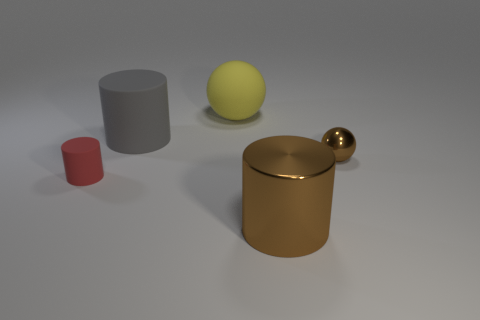What number of other things are the same material as the yellow thing?
Provide a succinct answer. 2. What is the material of the gray cylinder?
Offer a terse response. Rubber. What number of small objects are rubber cylinders or brown matte cylinders?
Keep it short and to the point. 1. How many matte things are right of the red thing?
Provide a succinct answer. 2. Is there a tiny shiny ball of the same color as the tiny matte cylinder?
Your answer should be very brief. No. There is a red matte object that is the same size as the brown sphere; what shape is it?
Ensure brevity in your answer.  Cylinder. What number of brown objects are either small spheres or large shiny things?
Provide a short and direct response. 2. How many red matte cylinders have the same size as the gray object?
Provide a succinct answer. 0. What is the shape of the big metallic thing that is the same color as the metal ball?
Make the answer very short. Cylinder. What number of objects are small purple rubber cylinders or things behind the big brown shiny cylinder?
Your response must be concise. 4. 